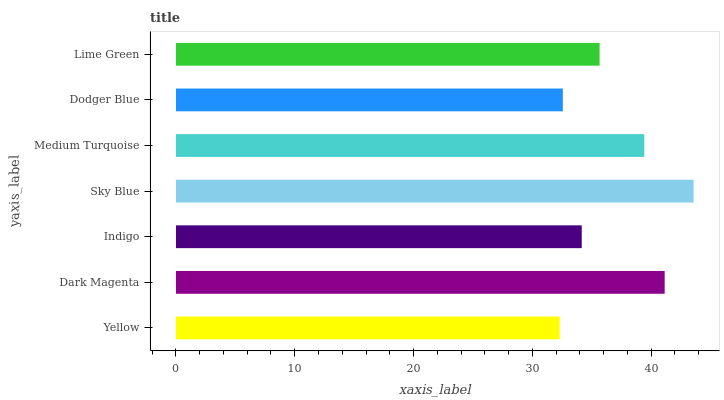Is Yellow the minimum?
Answer yes or no. Yes. Is Sky Blue the maximum?
Answer yes or no. Yes. Is Dark Magenta the minimum?
Answer yes or no. No. Is Dark Magenta the maximum?
Answer yes or no. No. Is Dark Magenta greater than Yellow?
Answer yes or no. Yes. Is Yellow less than Dark Magenta?
Answer yes or no. Yes. Is Yellow greater than Dark Magenta?
Answer yes or no. No. Is Dark Magenta less than Yellow?
Answer yes or no. No. Is Lime Green the high median?
Answer yes or no. Yes. Is Lime Green the low median?
Answer yes or no. Yes. Is Sky Blue the high median?
Answer yes or no. No. Is Medium Turquoise the low median?
Answer yes or no. No. 